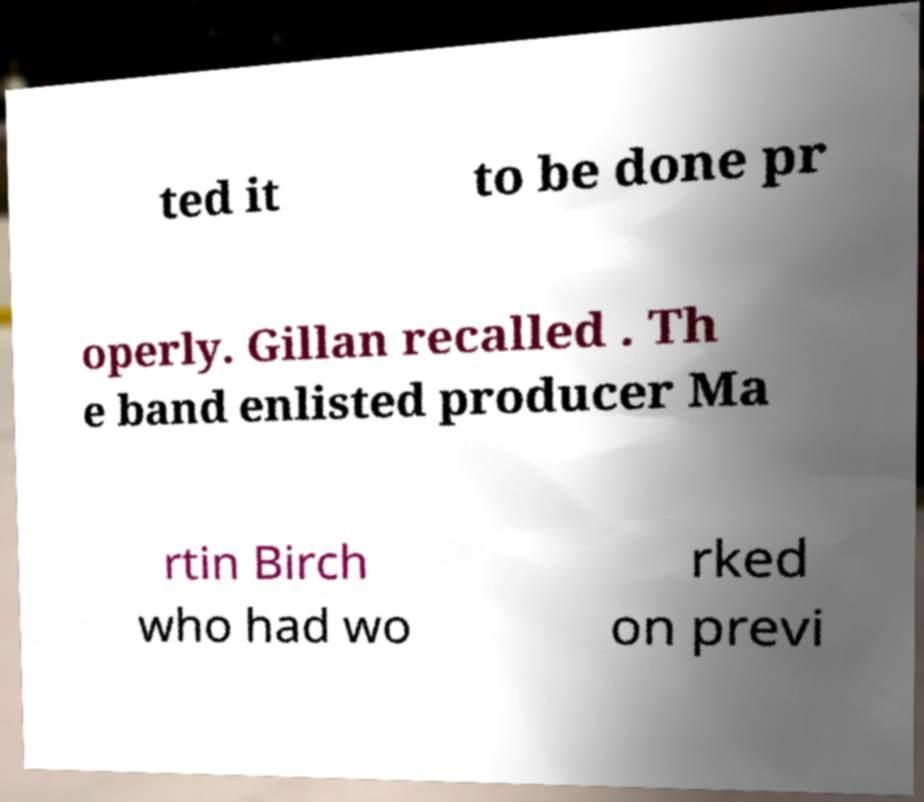Could you extract and type out the text from this image? ted it to be done pr operly. Gillan recalled . Th e band enlisted producer Ma rtin Birch who had wo rked on previ 